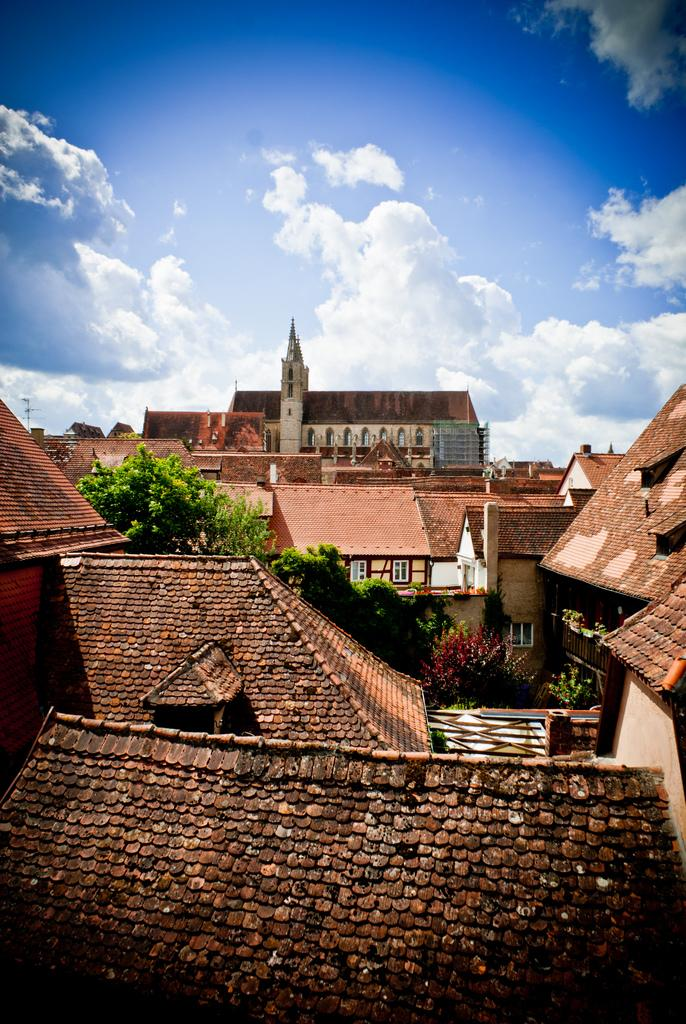What type of structures can be seen in the image? There are buildings in the image. What other natural elements are present in the image? There are trees in the image. What can be seen in the background of the image? The sky is visible behind the buildings. What type of doll is sitting on the society in the image? There is no doll or society present in the image. How many pickles are hanging from the trees in the image? There are no pickles present in the image; it features buildings and trees. 